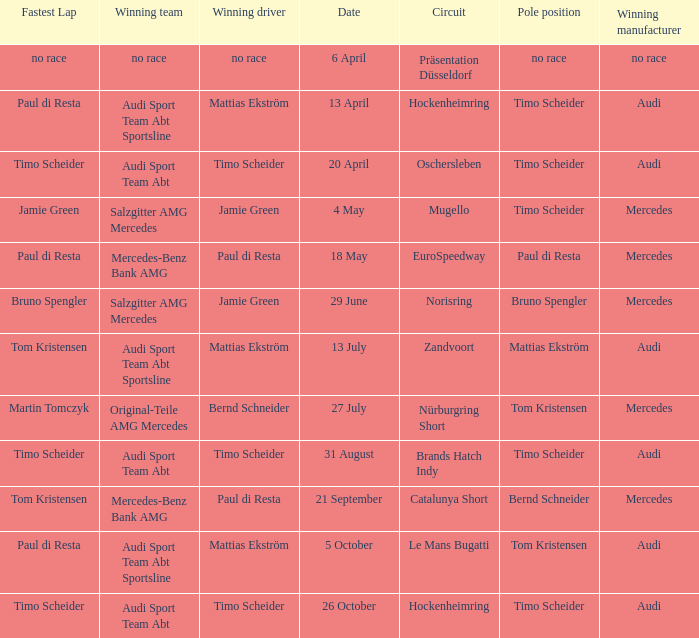Who is the winning driver of the Oschersleben circuit with Timo Scheider as the pole position? Timo Scheider. 